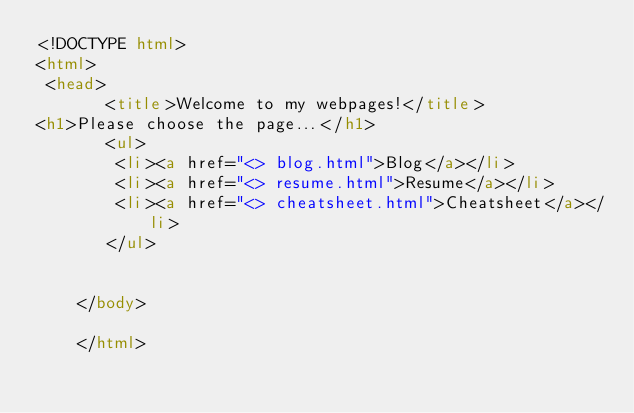Convert code to text. <code><loc_0><loc_0><loc_500><loc_500><_HTML_><!DOCTYPE html>
<html>
 <head>
       <title>Welcome to my webpages!</title>
<h1>Please choose the page...</h1>
       <ul>
        <li><a href="<> blog.html">Blog</a></li>
        <li><a href="<> resume.html">Resume</a></li>
        <li><a href="<> cheatsheet.html">Cheatsheet</a></li>
       </ul>


    </body>

    </html></code> 